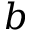<formula> <loc_0><loc_0><loc_500><loc_500>b</formula> 